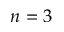Convert formula to latex. <formula><loc_0><loc_0><loc_500><loc_500>n = 3</formula> 